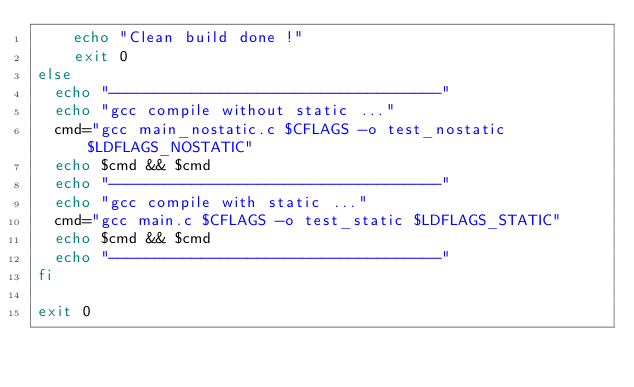Convert code to text. <code><loc_0><loc_0><loc_500><loc_500><_Bash_>    echo "Clean build done !"
    exit 0
else
	echo "------------------------------------"
	echo "gcc compile without static ..."
	cmd="gcc main_nostatic.c $CFLAGS -o test_nostatic $LDFLAGS_NOSTATIC"
	echo $cmd && $cmd
	echo "------------------------------------"
	echo "gcc compile with static ..."
	cmd="gcc main.c $CFLAGS -o test_static $LDFLAGS_STATIC"
	echo $cmd && $cmd
	echo "------------------------------------"
fi

exit 0</code> 